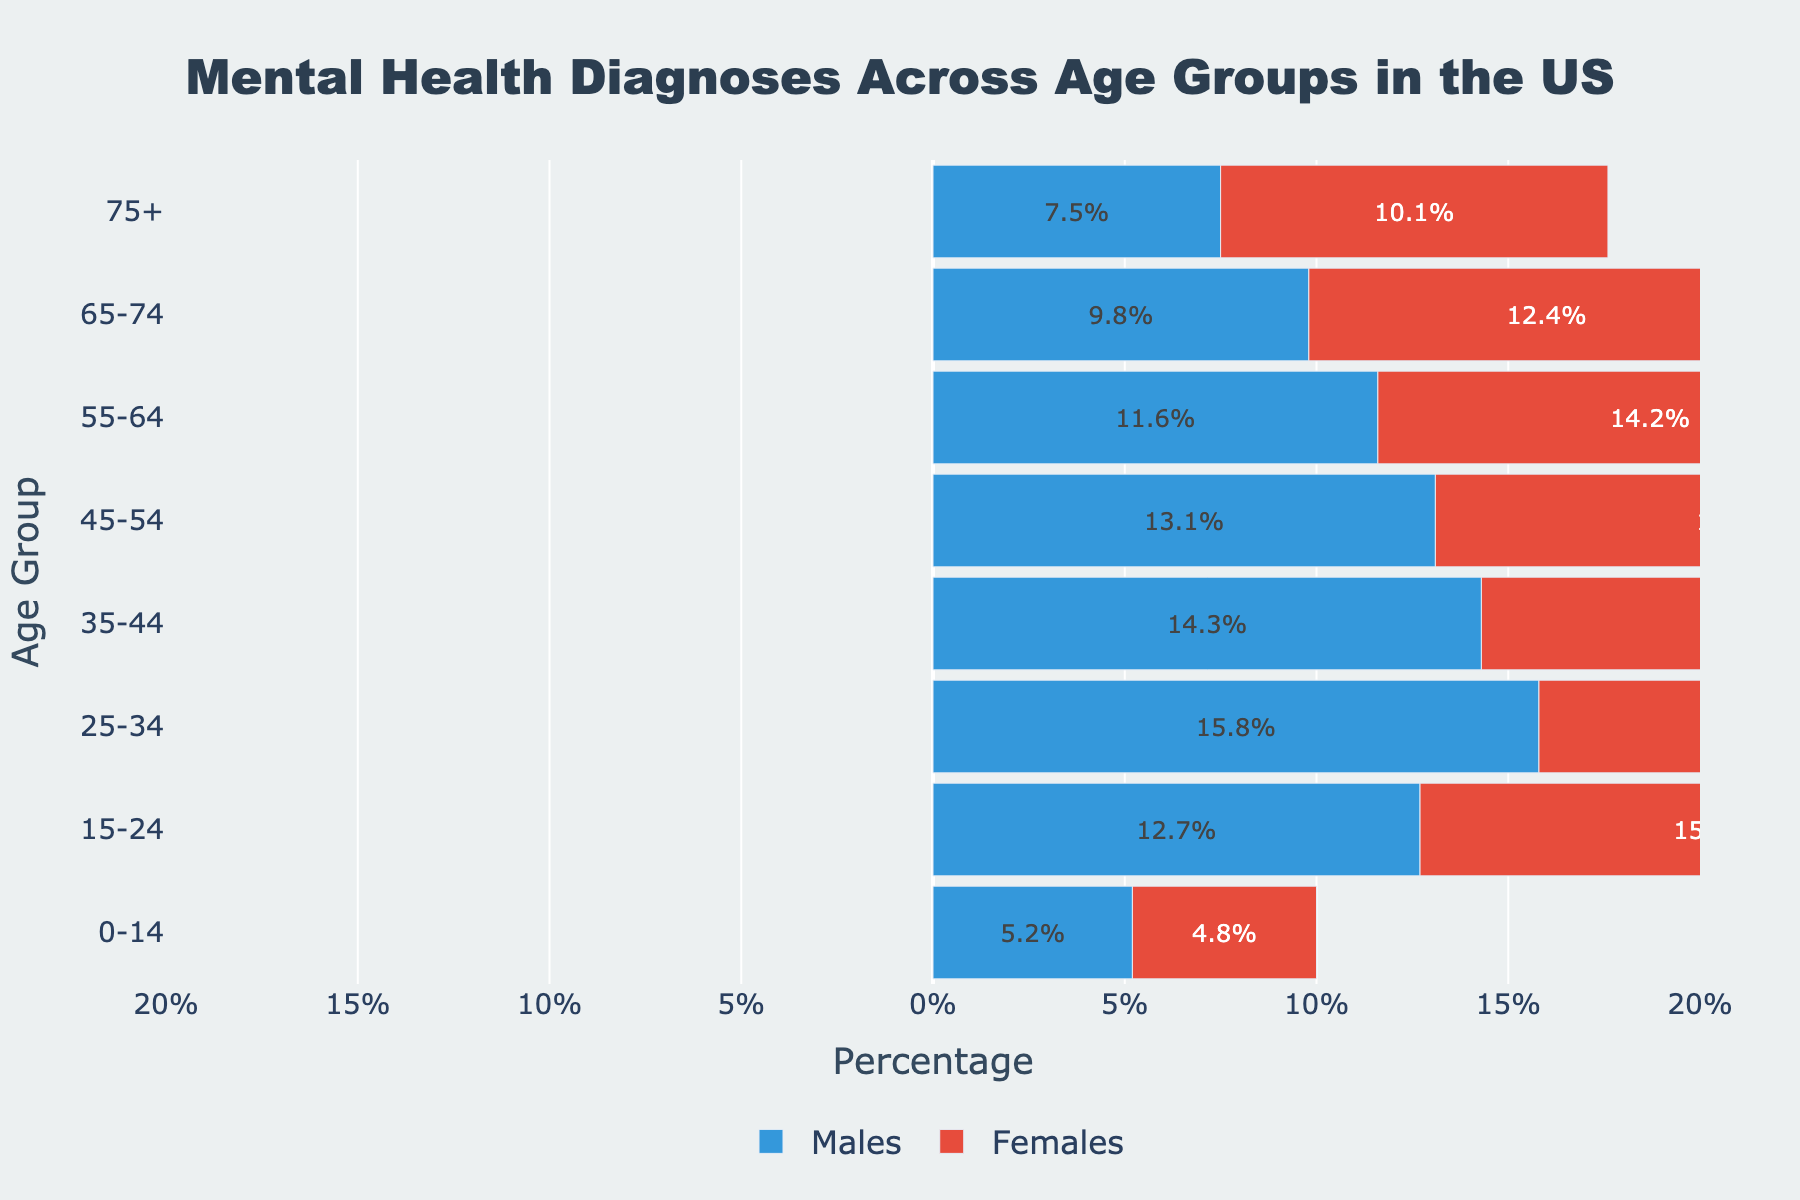What is the title of the figure? The title of the figure is typically located at the top and provides a brief description of what the figure represents. In this case, the title is "Mental Health Diagnoses Across Age Groups in the US."
Answer: Mental Health Diagnoses Across Age Groups in the US How many age groups are represented in the figure? Count the number of categories along the y-axis, which are the age groups. The y-axis starts with "0-14" and ends with "75+." There are 8 age groups in total.
Answer: 8 Which age group has the highest percentage of females diagnosed with mental health issues? Look at the lengths of the red bars (representing females) and identify the age group with the longest bar. The "25-34" age group has the highest percentage at 18.2%.
Answer: 25-34 What is the difference in the percentage of mental health diagnoses between males and females in the 15-24 age group? To find the difference, subtract the percentage of males from the percentage of females in the 15-24 group: 15.3% (females) - 12.7% (males) = 2.6%.
Answer: 2.6% Which age group shows a higher percentage of mental health diagnoses for males than the average percentage for all male age groups? First, calculate the average percentage for males across all age groups. Average = (5.2 + 12.7 + 15.8 + 14.3 + 13.1 + 11.6 + 9.8 + 7.5) / 8 = 90 / 8 = 11.25%. Next, compare each male percentage to this average. Only the 15-24, 25-34, and 35-44 age groups have higher percentages than 11.25%.
Answer: 15-24, 25-34, 35-44 Which gender has a higher percentage of mental health diagnoses in the 55-64 age group? Compare the length of the bars for males and females in the 55-64 age group. The female bar (14.2%) is longer than the male bar (11.6%).
Answer: Females What general trend is observed in mental health diagnoses across age groups for males? Look at the lengths of the blue bars representing males across all age groups. Starting from the 0-14 group to the 75+ group, the bars generally show a decreasing trend.
Answer: Decreasing trend 